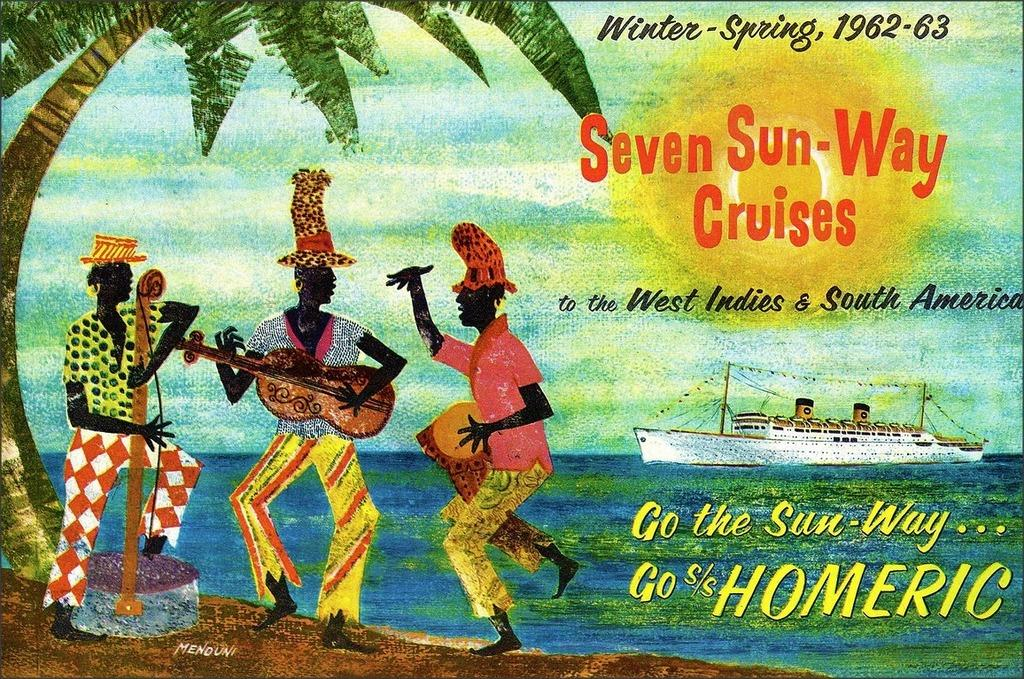<image>
Summarize the visual content of the image. An ad for Seven Sun Way Cruises from 1962 and 1963. 